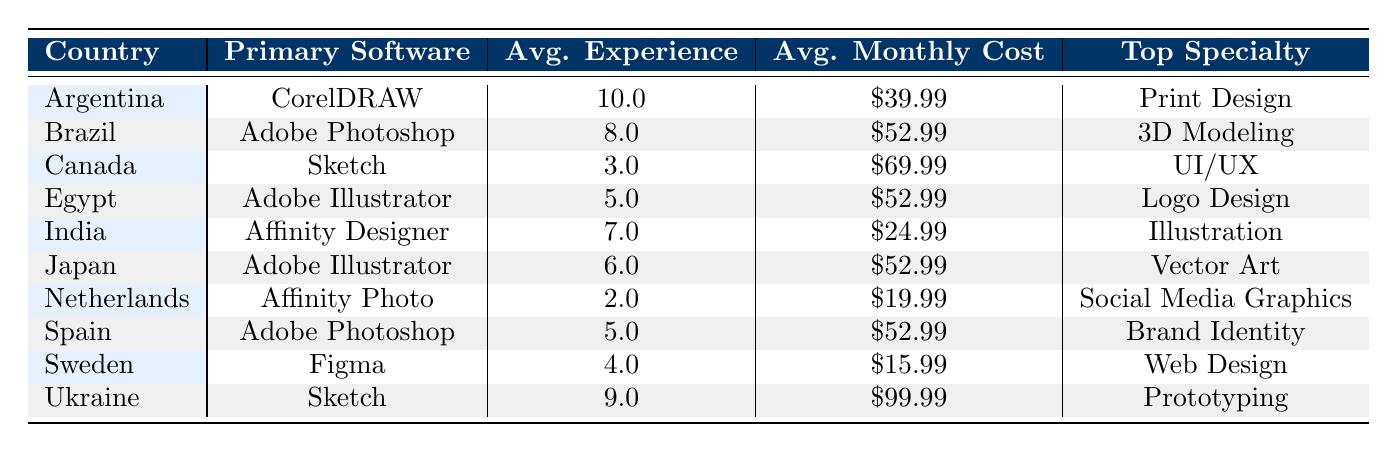What is the primary software used by designers from Brazil? The table shows that the primary software for the designer from Brazil (Lucas Silva) is Adobe Photoshop.
Answer: Adobe Photoshop Which country has the highest average years of experience among designers? The table lists Argentina with 10.0 years of experience as the highest average.
Answer: Argentina What is the average monthly software cost for designers using Adobe Illustrator? There are three designers using Adobe Illustrator: Fatima Al-Sayed ($52.99), Yuki Tanaka ($52.99), and another one in the same category. To find the average, sum these costs ($52.99 + $52.99 + $69.99) / 3 = $58.99.
Answer: $58.99 Is the average monthly software cost for designers in Spain higher than that in Sweden? The average monthly software cost for Spain is $52.99 and for Sweden it is $15.99. Since $52.99 is greater than $15.99, the statement is true.
Answer: Yes What is the top design specialty for the designer from India, and how does it compare to the designer from Canada? The top specialty for Aisha Patel from India is Illustration, while Liam Chen from Canada specializes in UI/UX. This comparison shows both have different specialties.
Answer: Illustration vs UI/UX Which country has the lowest average monthly software cost and what is the value? The table indicates that the Netherlands has the lowest average monthly software cost of $19.99.
Answer: $19.99 Calculate the total monthly software cost for all designers listed in the table. The total is calculated by summing each designer’s monthly cost: $52.99 + $69.99 + $24.99 + $39.99 + $52.99 + $15.99 + $52.99 + $19.99 + $99.99 + $52.99 = $458.90.
Answer: $458.90 Which designer has the longest years of experience, and what is their primary software? Mateo Fernandez from Argentina has the longest years of experience at 10 years, using CorelDRAW.
Answer: Mateo Fernandez, CorelDRAW What percentage of designers specialize in UI/UX compared to the total number of designers? There are 10 designers total, and only Liam Chen specializes in UI/UX. Therefore, the percentage is (1/10) * 100 = 10%.
Answer: 10% 